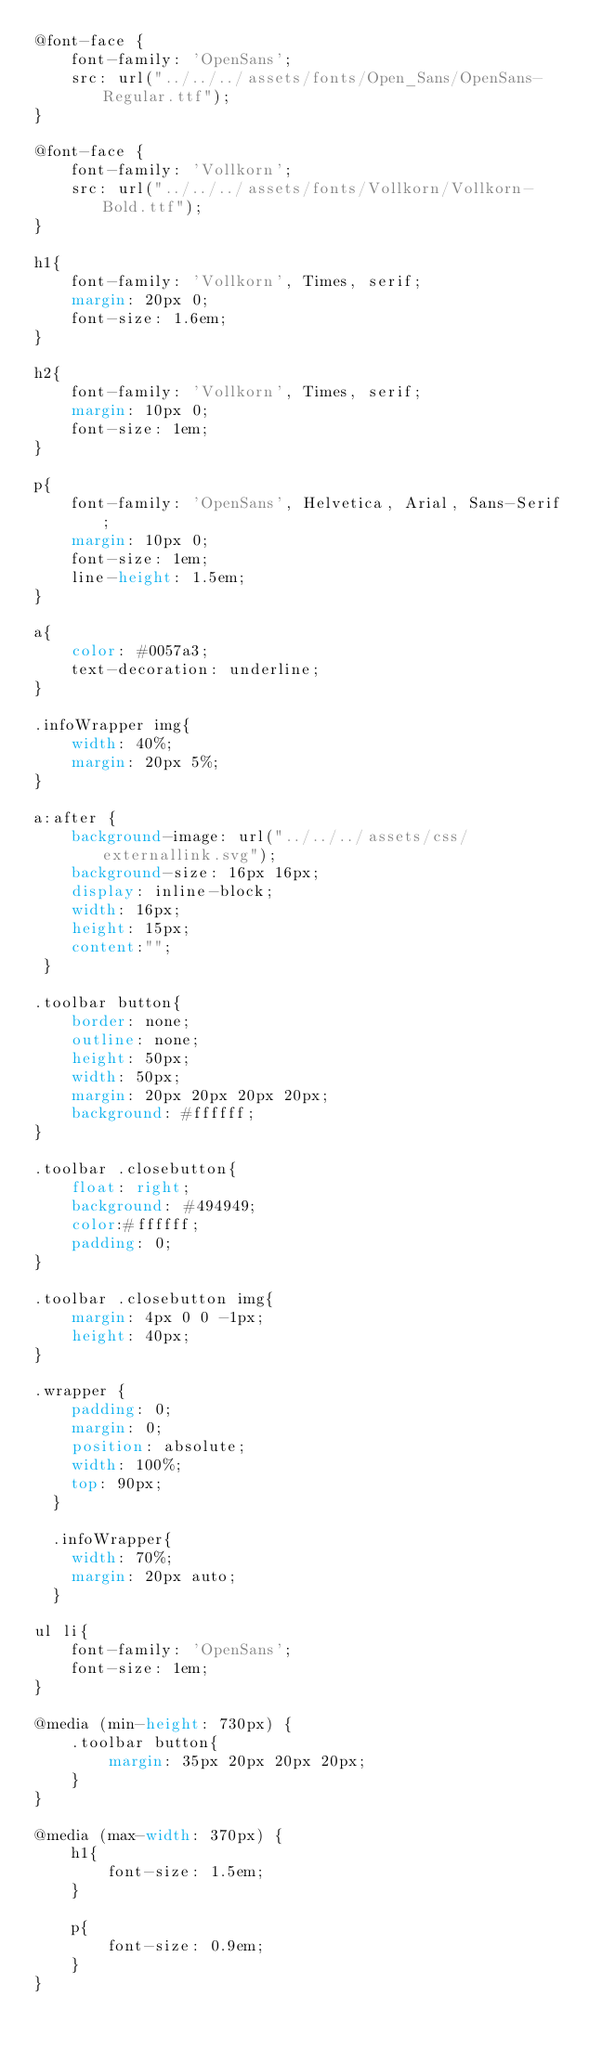<code> <loc_0><loc_0><loc_500><loc_500><_CSS_>@font-face {
    font-family: 'OpenSans';
    src: url("../../../assets/fonts/Open_Sans/OpenSans-Regular.ttf");
}

@font-face {
    font-family: 'Vollkorn';
    src: url("../../../assets/fonts/Vollkorn/Vollkorn-Bold.ttf");
}

h1{
    font-family: 'Vollkorn', Times, serif;
    margin: 20px 0;
    font-size: 1.6em;
}

h2{
    font-family: 'Vollkorn', Times, serif;
    margin: 10px 0;
    font-size: 1em;
}

p{
    font-family: 'OpenSans', Helvetica, Arial, Sans-Serif;
    margin: 10px 0;
    font-size: 1em;
    line-height: 1.5em;
}

a{
    color: #0057a3;
    text-decoration: underline;
}

.infoWrapper img{
    width: 40%;
    margin: 20px 5%;
}

a:after {
    background-image: url("../../../assets/css/externallink.svg");
    background-size: 16px 16px;
    display: inline-block;
    width: 16px; 
    height: 15px;
    content:"";
 }

.toolbar button{
    border: none;
    outline: none;
    height: 50px;
    width: 50px;
    margin: 20px 20px 20px 20px; 
    background: #ffffff;
}

.toolbar .closebutton{
    float: right; 
    background: #494949;
    color:#ffffff;
    padding: 0;
}

.toolbar .closebutton img{
    margin: 4px 0 0 -1px;
    height: 40px;
}

.wrapper {
    padding: 0;
    margin: 0;
    position: absolute;
    width: 100%;
    top: 90px;
  }
  
  .infoWrapper{
    width: 70%;
    margin: 20px auto;
  }

ul li{
    font-family: 'OpenSans';
    font-size: 1em;
}

@media (min-height: 730px) {
    .toolbar button{
        margin: 35px 20px 20px 20px; 
    }
}

@media (max-width: 370px) {
    h1{
        font-size: 1.5em;
    }

    p{
        font-size: 0.9em;
    }
}</code> 